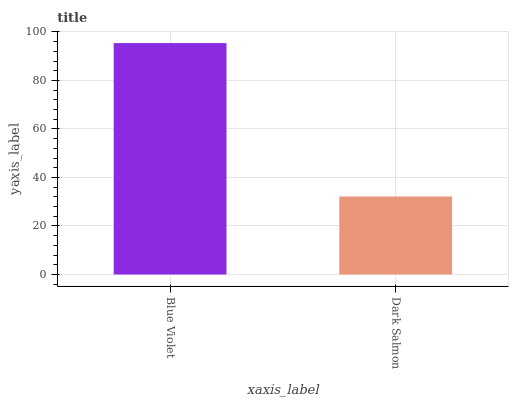Is Dark Salmon the minimum?
Answer yes or no. Yes. Is Blue Violet the maximum?
Answer yes or no. Yes. Is Dark Salmon the maximum?
Answer yes or no. No. Is Blue Violet greater than Dark Salmon?
Answer yes or no. Yes. Is Dark Salmon less than Blue Violet?
Answer yes or no. Yes. Is Dark Salmon greater than Blue Violet?
Answer yes or no. No. Is Blue Violet less than Dark Salmon?
Answer yes or no. No. Is Blue Violet the high median?
Answer yes or no. Yes. Is Dark Salmon the low median?
Answer yes or no. Yes. Is Dark Salmon the high median?
Answer yes or no. No. Is Blue Violet the low median?
Answer yes or no. No. 